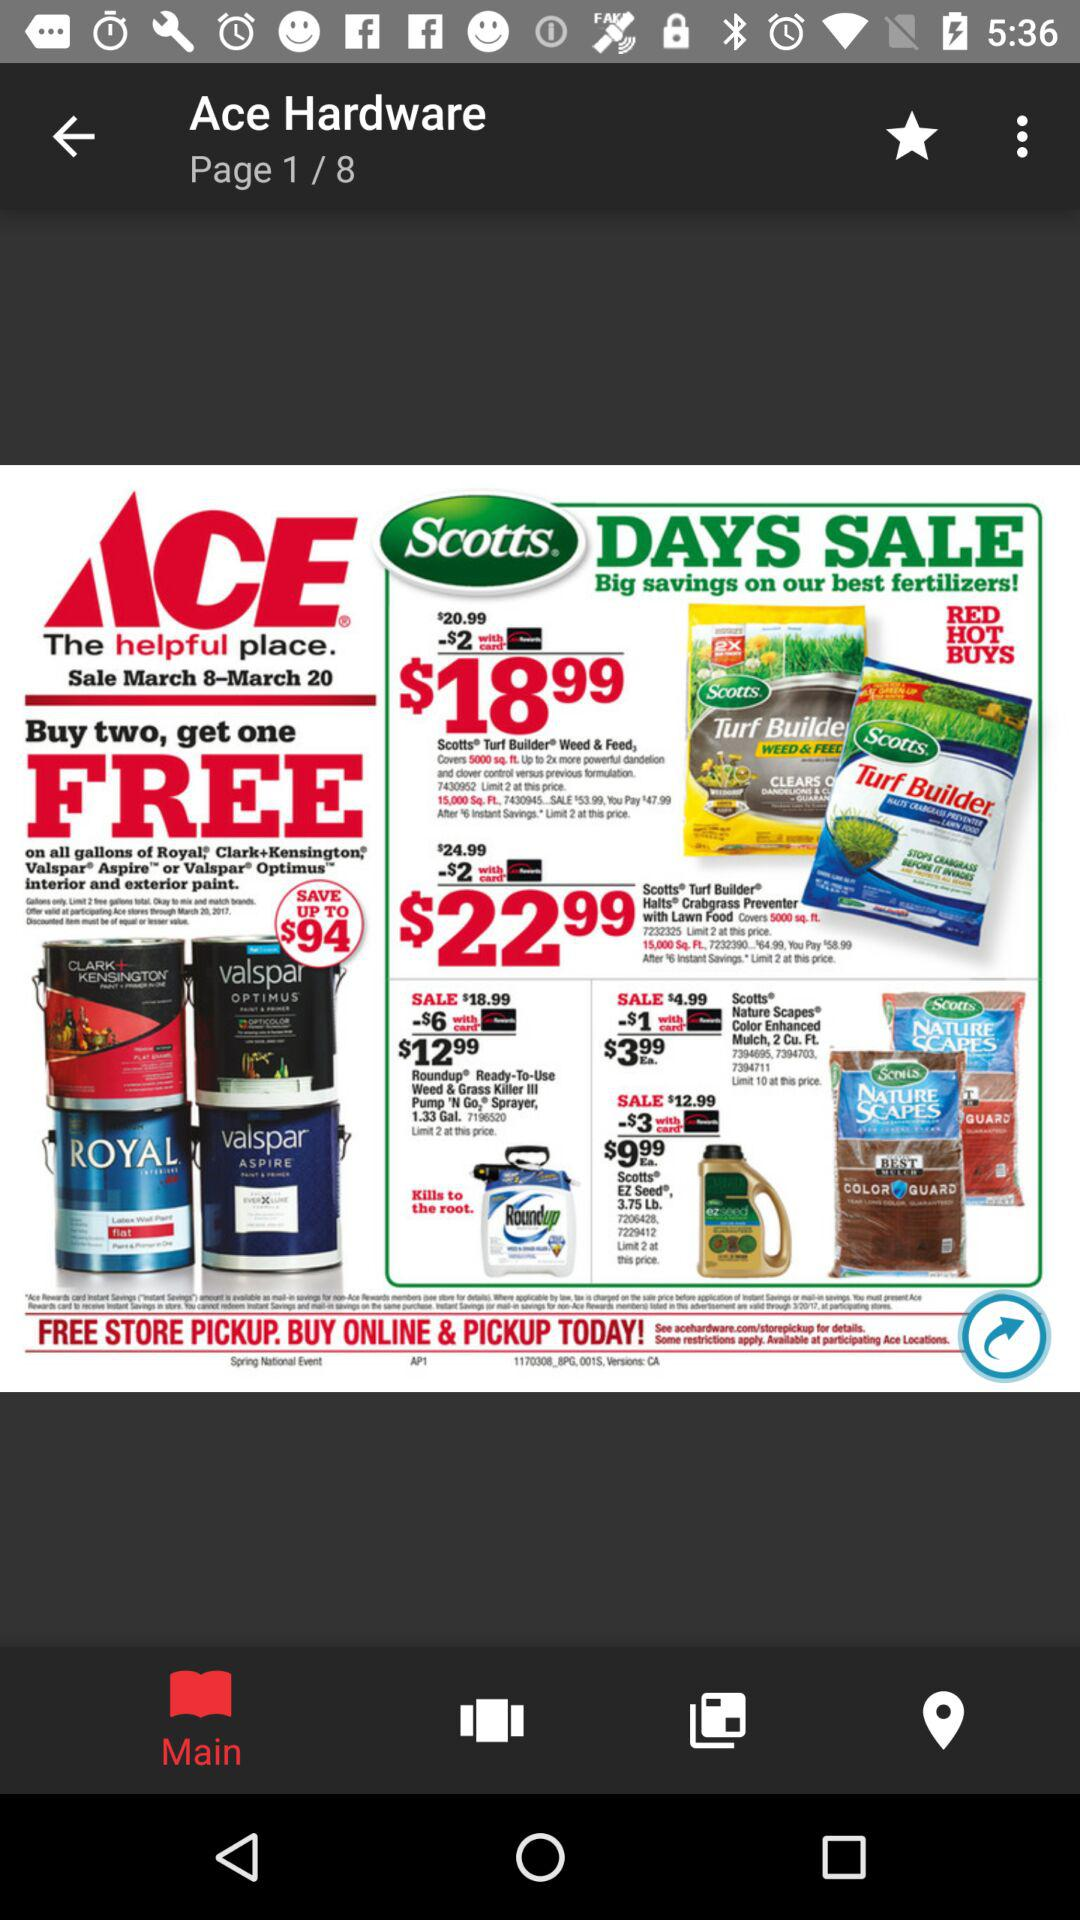What is the total number of pages? The total number of pages is 8. 